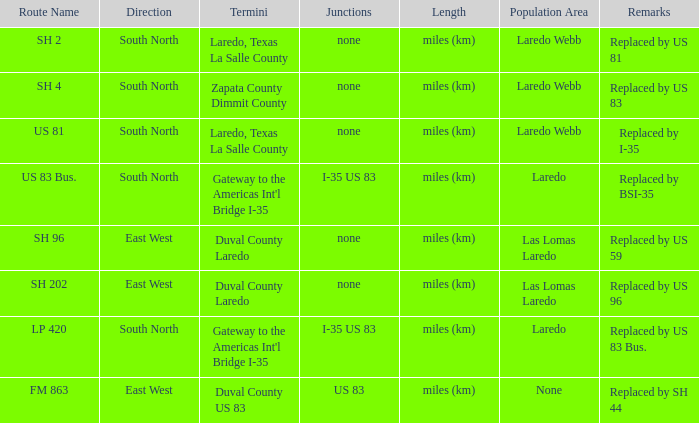Which roadways have a remark stating they were "replaced by us 81"? SH 2. 